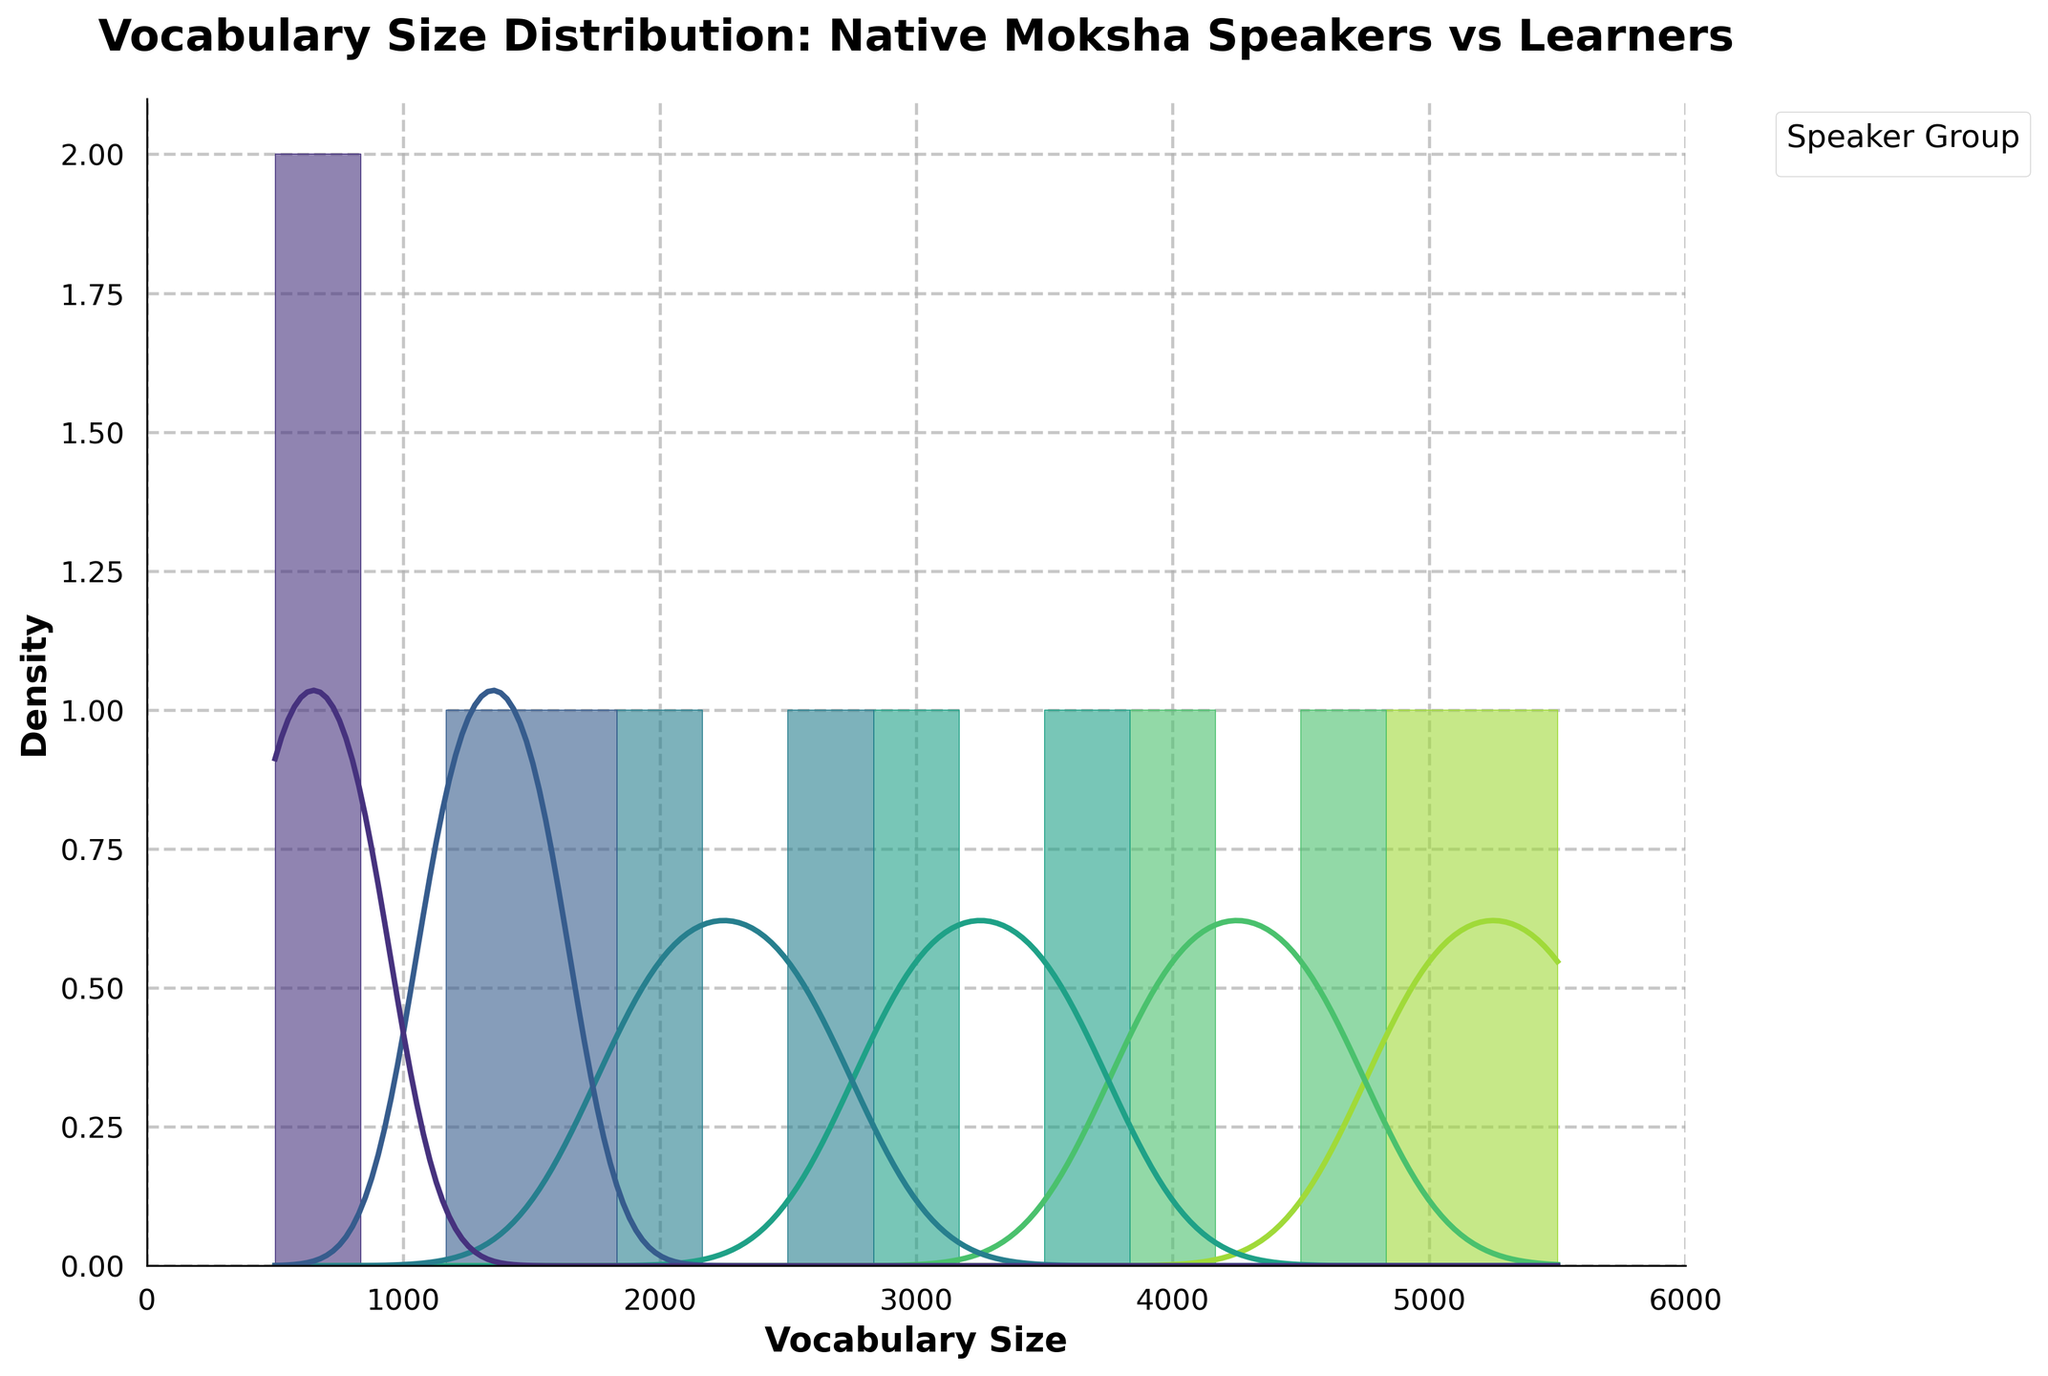What's the title of the figure? The title is displayed at the top of the figure as a text element. It provides the context of the histogram and KDE plot.
Answer: Vocabulary Size Distribution: Native Moksha Speakers vs Learners What is the x-axis representing? The x-axis label indicates the variable being measured, which is shown as a text element at the bottom of the plot.
Answer: Vocabulary Size Which speaker group has the highest vocabulary size according to the KDE curve? The highest point of the KDE curve represents the mode of the vocabulary size distribution for each speaker group. By comparing the peaks, the group with the highest peak at the largest vocabulary size can be identified.
Answer: Native speaker (elderly) How does the vocabulary size of Beginner learners compare to Advanced learners? The histogram bars and KDE curves for Beginner learners and Advanced learners show the distribution of vocabulary sizes. Beginner learners have vocabulary sizes ranging from 500 to 800, while Advanced learners range from 2000 to 2500.
Answer: Advanced learners have a larger vocabulary size Are there any speaker groups with overlapping vocabulary sizes? Overlapping histogram bars and KDE curves indicate where speaker groups share similar vocabulary sizes. Specifically, check for overlaps between different colors.
Answer: Yes, Intermediate learners and Advanced learners have some overlapping vocabulary sizes What is the range of vocabulary sizes for Native speakers (urban)? The range of vocabulary sizes can be determined by observing the spread of the histogram bars and KDE curve for the Native speakers (urban) group along the x-axis.
Answer: 4000 to 4500 Which speaker group has the smallest vocabulary size? The smallest vocabulary size corresponds to the leftmost point of the histogram/KDE curve for each speaker group. Identify the group with the furthest left point.
Answer: Beginner learner How do the vocabulary sizes of Native speakers (rural) compare to Native speakers (elderly)? By examining the KDE curves and histogram bars for both groups, the distribution and central tendency of vocabulary sizes can be compared. Native speakers (rural) range from 3000 to 3500, while Native speakers (elderly) range from 5000 to 5500.
Answer: Native speakers (elderly) have larger vocabulary sizes What's the difference in peak vocabulary sizes between Intermediate learners and Native speakers (urban)? Identify the highest points on the KDE curves for both Intermediate learners and Native speakers (urban). Then, subtract the vocabulary size values associated with these peaks.
Answer: 4500 - 1500 = 3000 Is there a group whose vocabulary size distribution is symmetric, and if so, which one? Symmetric distributions have KDE curves that are mirrored around the central peak. Examine the shape of each group's KDE curve to identify any symmetry.
Answer: Native speaker (urban) 